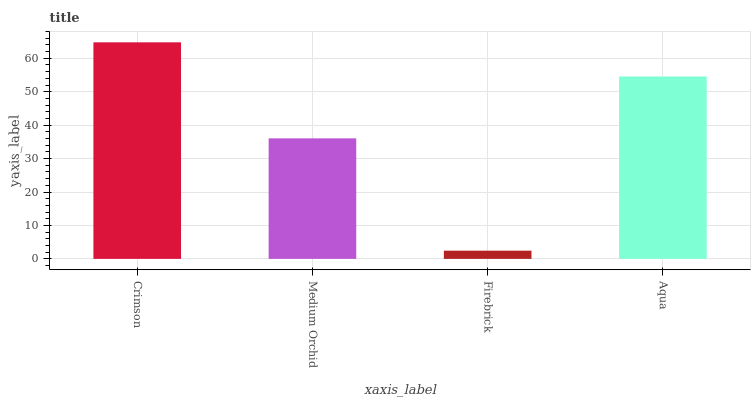Is Firebrick the minimum?
Answer yes or no. Yes. Is Crimson the maximum?
Answer yes or no. Yes. Is Medium Orchid the minimum?
Answer yes or no. No. Is Medium Orchid the maximum?
Answer yes or no. No. Is Crimson greater than Medium Orchid?
Answer yes or no. Yes. Is Medium Orchid less than Crimson?
Answer yes or no. Yes. Is Medium Orchid greater than Crimson?
Answer yes or no. No. Is Crimson less than Medium Orchid?
Answer yes or no. No. Is Aqua the high median?
Answer yes or no. Yes. Is Medium Orchid the low median?
Answer yes or no. Yes. Is Medium Orchid the high median?
Answer yes or no. No. Is Firebrick the low median?
Answer yes or no. No. 